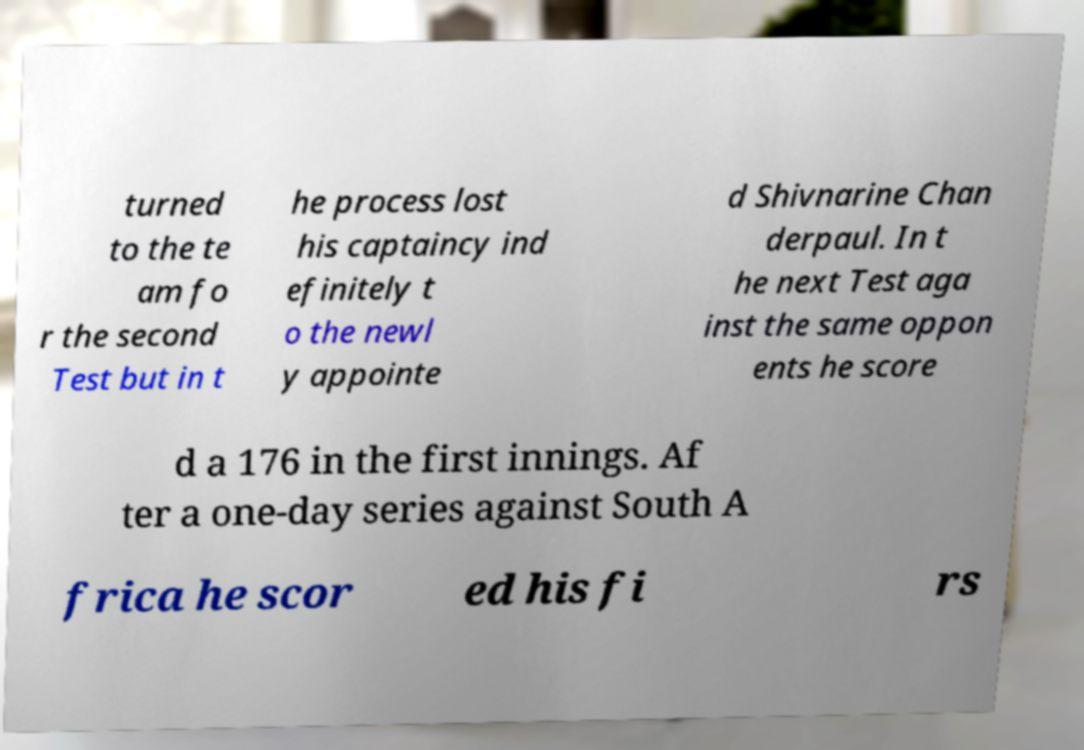Could you extract and type out the text from this image? turned to the te am fo r the second Test but in t he process lost his captaincy ind efinitely t o the newl y appointe d Shivnarine Chan derpaul. In t he next Test aga inst the same oppon ents he score d a 176 in the first innings. Af ter a one-day series against South A frica he scor ed his fi rs 